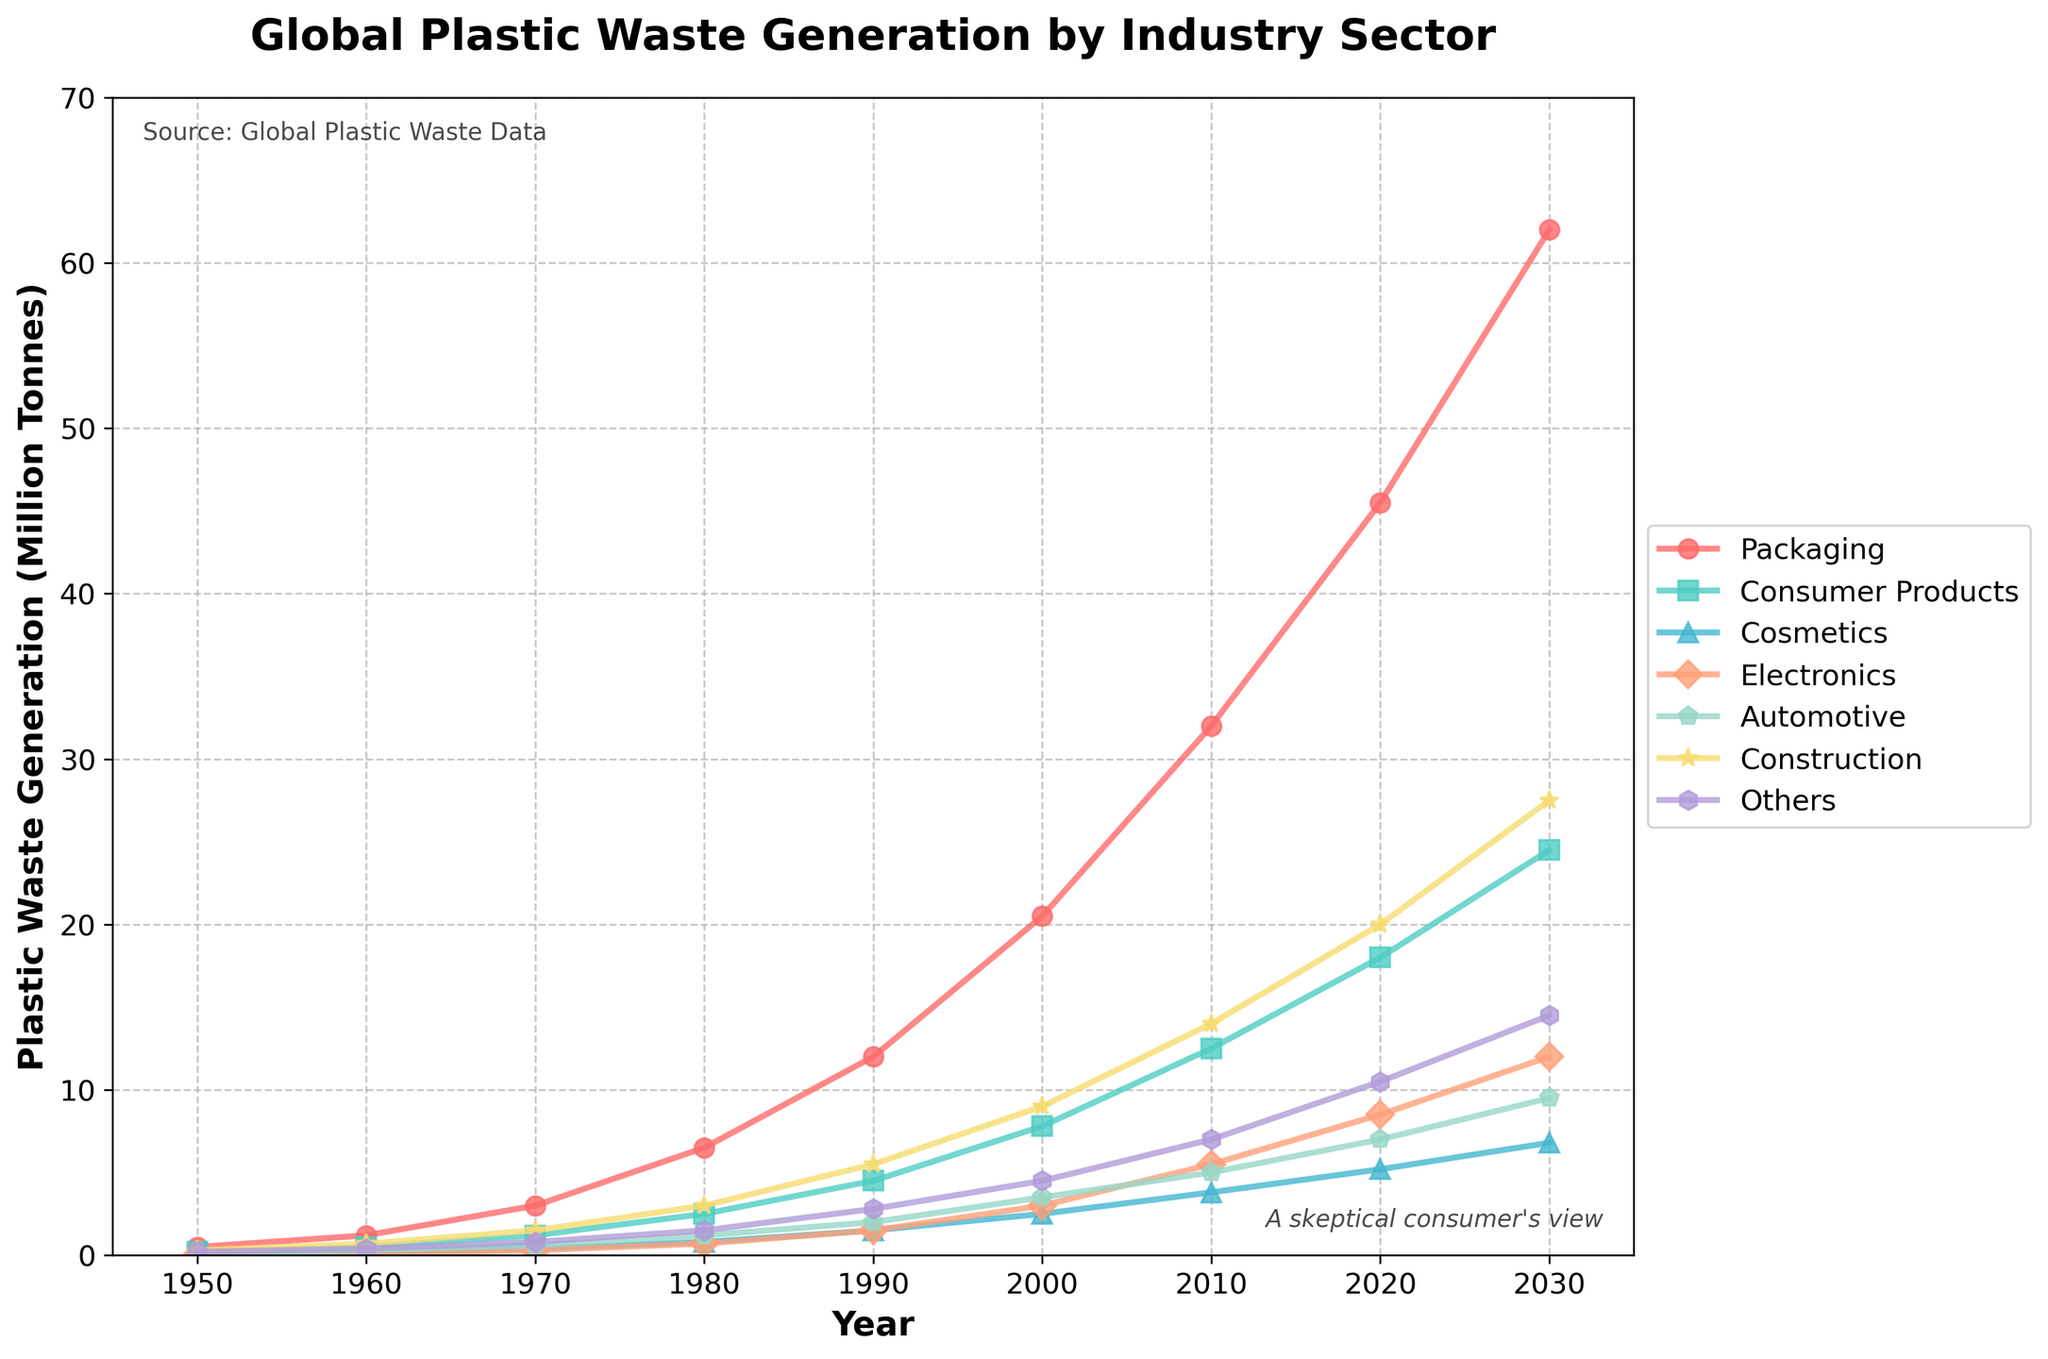Which industry sector had the most significant increase in plastic waste generation from 1950 to 2020? First, look at the plastic waste values for each sector in 1950 and 2020. Calculate the difference for each sector between these years. Identify the sector with the highest increase. The sector 'Packaging' had changes from 0.5 in 1950 to 45.5 in 2020, which is an increase of 45.0, the highest among all sectors.
Answer: Packaging How did the plastic waste generation for the automotive sector compare with the construction sector in 1980? Check the values for both sectors in 1980. The automotive sector had 1.2 million tonnes, whereas the construction sector had 3.0 million tonnes. Thus, the construction sector generated more waste.
Answer: Construction sector generated more waste What’s the combined plastic waste generation for the electronics and cosmetics sectors in the year 2000? Sum the plastic waste values for electronics (3.0) and cosmetics (2.5) in 2000. 3.0 + 2.5 equals 5.5 million tonnes.
Answer: 5.5 million tonnes What can you infer about the trend for the packaging sector from 1950 to 2030? Observing the plot indicates a consistent upward trend for the packaging sector from 1950 (0.5) to 2030 (62.0), showing a steep increase over time.
Answer: Consistent upward trend In 2030, which sector is projected to generate more plastic waste, consumer products or automotive? Compare the projected values for consumer products (24.5) and automotive (9.5) in 2030. Consumer products have a higher projected waste generation.
Answer: Consumer products By how much did plastic waste generation in the 'Others' category increase from 1990 to 2020? Calculate the difference in the 'Others' category between 1990 (2.8 million tonnes) and 2020 (10.5 million tonnes). The difference is 10.5 - 2.8 = 7.7 million tonnes.
Answer: 7.7 million tonnes Which sector had the smallest plastic waste generation in 1950? Compare the values for all sectors in 1950: Packaging (0.5), Consumer Products (0.2), Cosmetics (0.1), Electronics (0.05), Automotive (0.1), Construction (0.3), Others (0.2). The smallest value is for Electronics (0.05).
Answer: Electronics What's the average plastic waste generation for the construction sector across the provided years? Sum the values for the construction sector (0.3, 0.7, 1.5, 3.0, 5.5, 9.0, 14.0, 20.0, 27.5) and divide by 9, the number of years. The sum is 81.5, and the average is 81.5 / 9 = 9.06.
Answer: 9.06 million tonnes How did the plastic waste generation of the cosmetics sector compare to consumer products in 2020? Check the values for cosmetics (5.2) and consumer products (18.0) in 2020. Consumer products had a notably higher amount of waste.
Answer: Consumer products generated more waste By what factor did the packaging sector's plastic waste generation increase from 1970 to 2030? Divide the 2030 value (62.0) by the 1970 value (3.0). The factor of increase is 62.0 / 3.0 = 20.67.
Answer: 20.67 